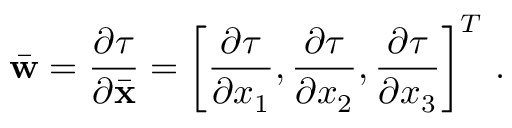<formula> <loc_0><loc_0><loc_500><loc_500>\bar { w } = \frac { \partial \tau } { \partial \bar { x } } = \left [ \frac { \partial \tau } { \partial x _ { 1 } } , \frac { \partial \tau } { \partial x _ { 2 } } , \frac { \partial \tau } { \partial x _ { 3 } } \right ] ^ { T } \, .</formula> 